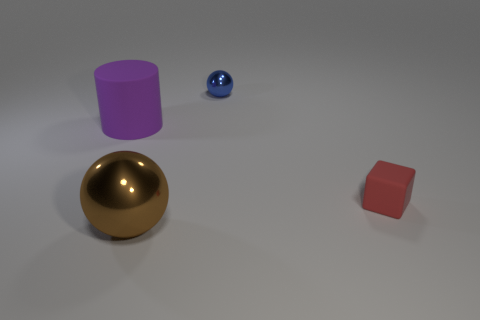There is a tiny object to the right of the tiny blue object that is left of the cube; what shape is it?
Provide a succinct answer. Cube. There is a tiny thing in front of the metal sphere behind the large purple matte object; are there any rubber cylinders in front of it?
Provide a short and direct response. No. There is a shiny ball that is the same size as the rubber cube; what is its color?
Your answer should be very brief. Blue. What shape is the object that is both in front of the tiny blue metallic sphere and behind the small red object?
Your answer should be very brief. Cylinder. There is a metal sphere that is behind the shiny sphere in front of the tiny red rubber thing; how big is it?
Your answer should be compact. Small. How many tiny spheres are the same color as the block?
Keep it short and to the point. 0. What number of other things are the same size as the purple matte thing?
Your answer should be compact. 1. There is a thing that is both in front of the tiny sphere and right of the big brown sphere; what size is it?
Keep it short and to the point. Small. How many small red objects are the same shape as the big metallic thing?
Offer a very short reply. 0. What is the cylinder made of?
Ensure brevity in your answer.  Rubber. 